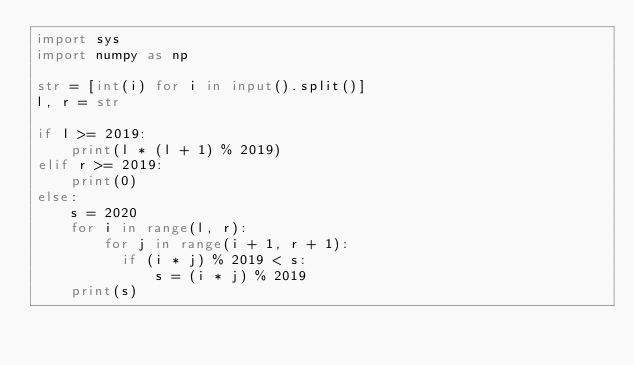<code> <loc_0><loc_0><loc_500><loc_500><_Python_>import sys
import numpy as np

str = [int(i) for i in input().split()]
l, r = str

if l >= 2019:
    print(l * (l + 1) % 2019)
elif r >= 2019:
    print(0)
else:
    s = 2020
    for i in range(l, r):
        for j in range(i + 1, r + 1):
          if (i * j) % 2019 < s:
              s = (i * j) % 2019
    print(s)

</code> 